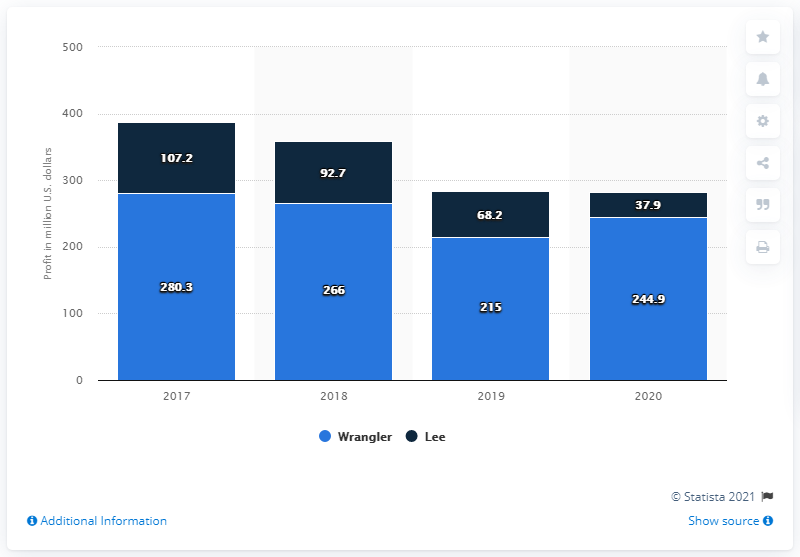Could you provide insights into how the revenues of Wrangler and Lee relate to each other over the years? Analyzing the provided data, Wrangler consistently achieved higher revenues than Lee from 2017 to 2020 in the U.S. market. While both brands experienced a downward revenue trend during these years, Wrangler maintained a sizable advantage over Lee in terms of total revenue. 